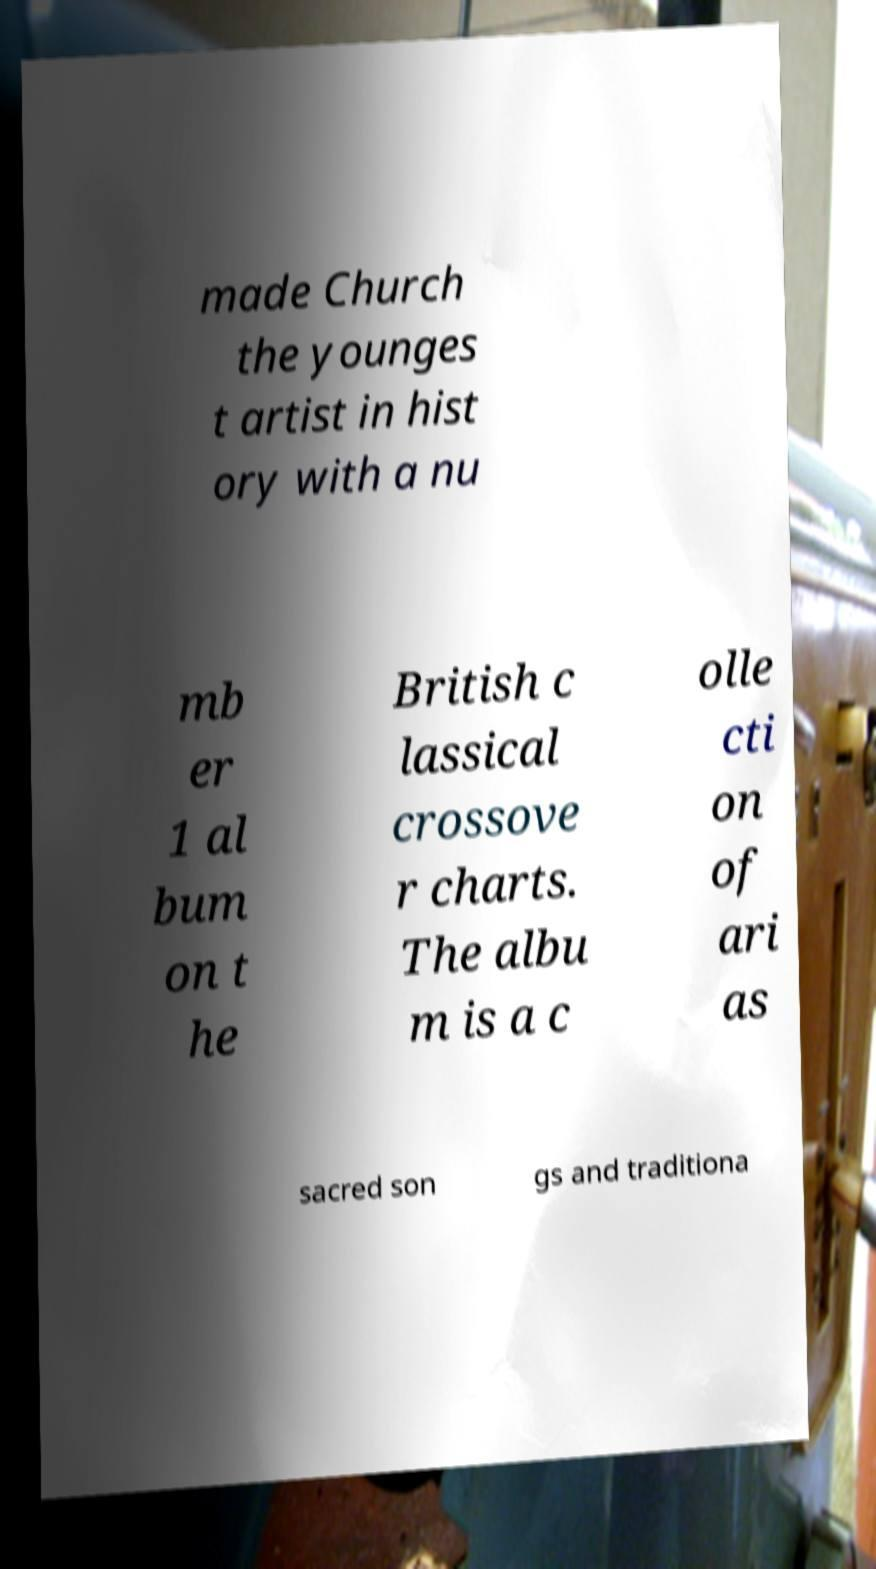I need the written content from this picture converted into text. Can you do that? made Church the younges t artist in hist ory with a nu mb er 1 al bum on t he British c lassical crossove r charts. The albu m is a c olle cti on of ari as sacred son gs and traditiona 